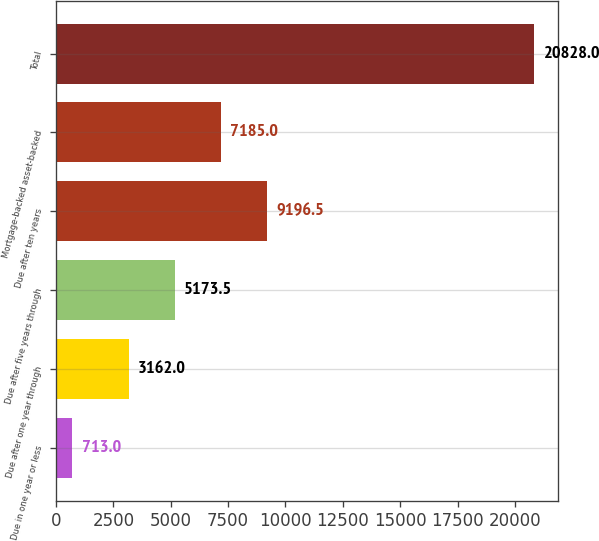Convert chart. <chart><loc_0><loc_0><loc_500><loc_500><bar_chart><fcel>Due in one year or less<fcel>Due after one year through<fcel>Due after five years through<fcel>Due after ten years<fcel>Mortgage-backed asset-backed<fcel>Total<nl><fcel>713<fcel>3162<fcel>5173.5<fcel>9196.5<fcel>7185<fcel>20828<nl></chart> 